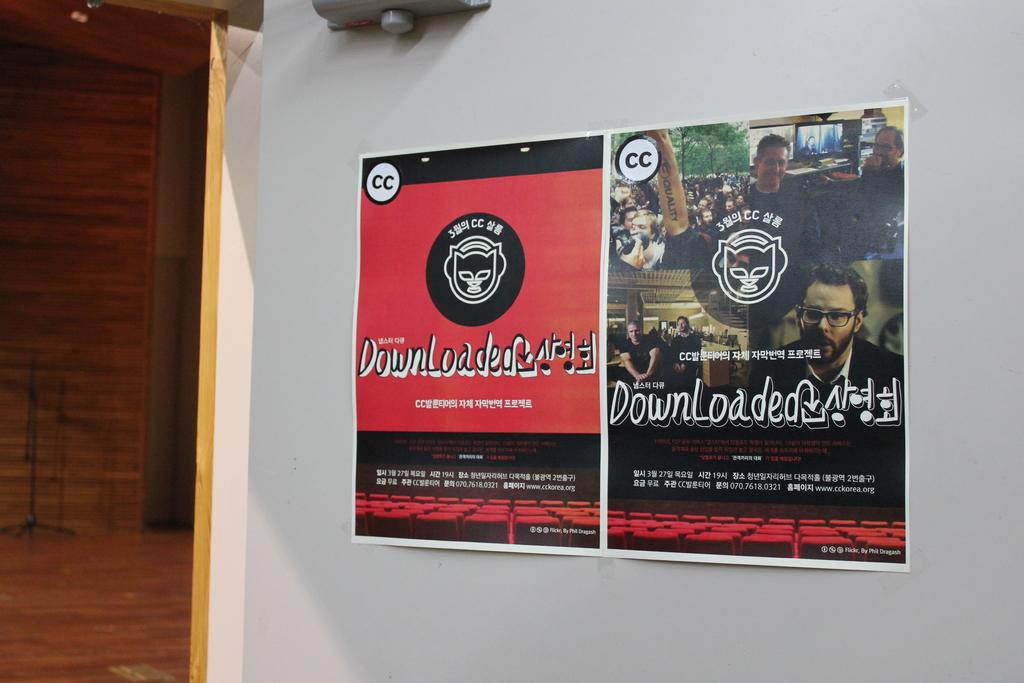<image>
Render a clear and concise summary of the photo. an open poster with the word 'downloaded' on it 